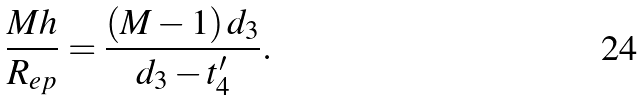<formula> <loc_0><loc_0><loc_500><loc_500>\frac { M h } { R _ { e p } } = \frac { ( M - 1 ) \, d _ { 3 } } { d _ { 3 } - t ^ { \prime } _ { 4 } } .</formula> 